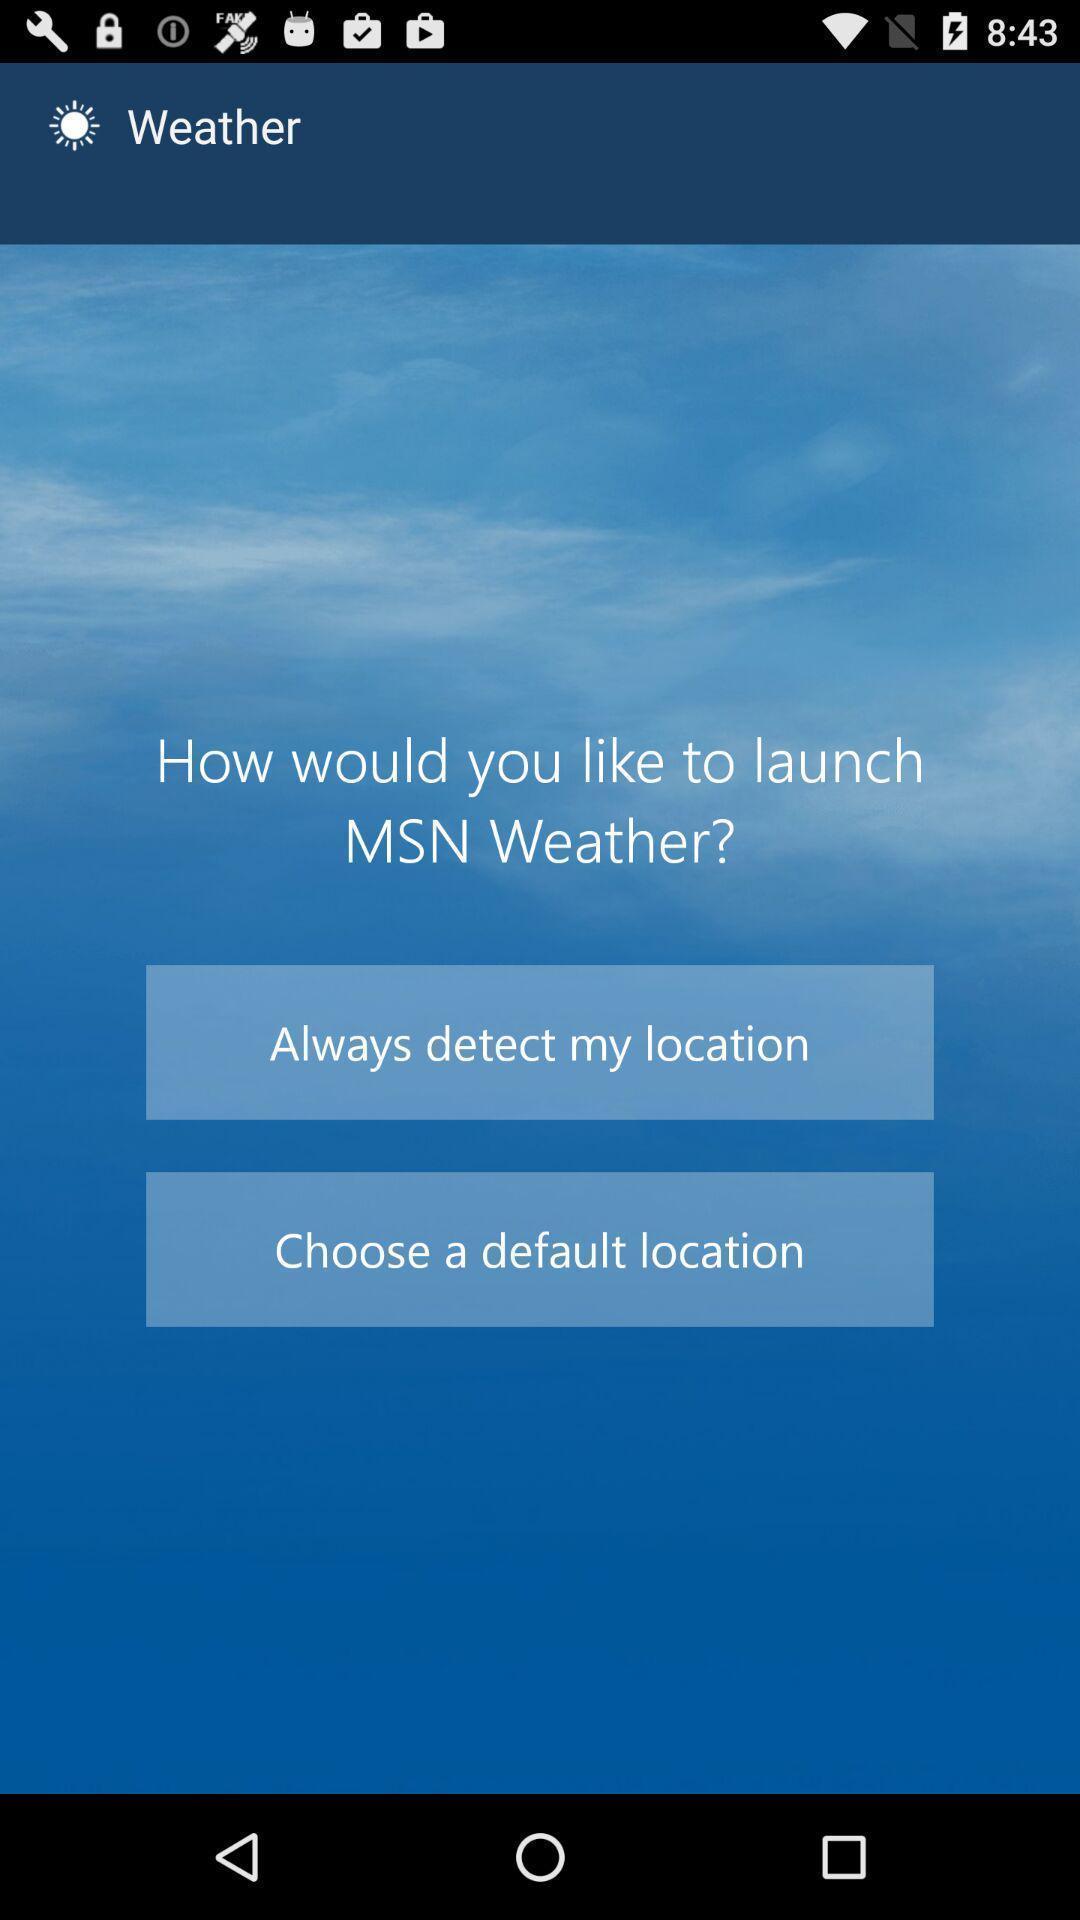Please provide a description for this image. Starting page. 